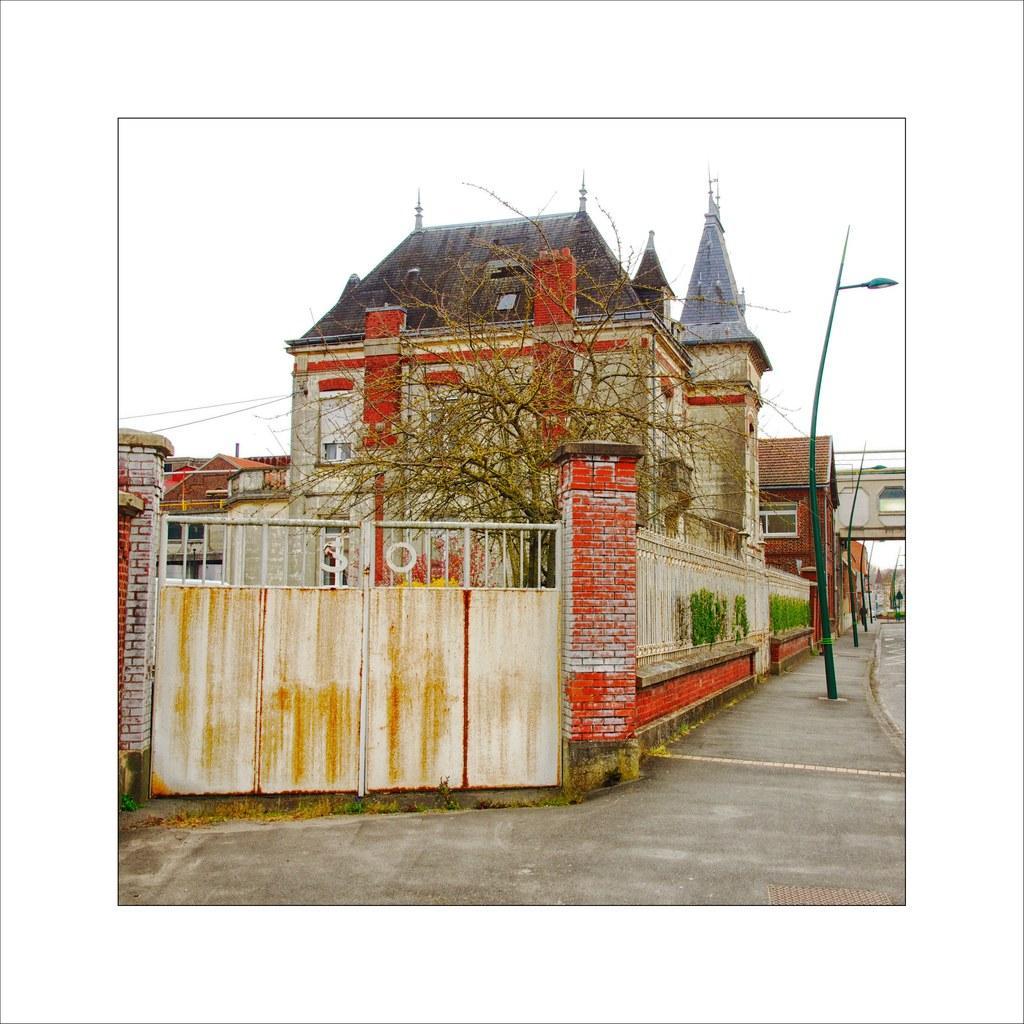Could you give a brief overview of what you see in this image? This image is clicked on the road. To the left there are buildings. In the foreground there is a gate to the wall. Behind the gate there is a tree. To the right there are street light poles on the walkway. At the top there is the sky. 